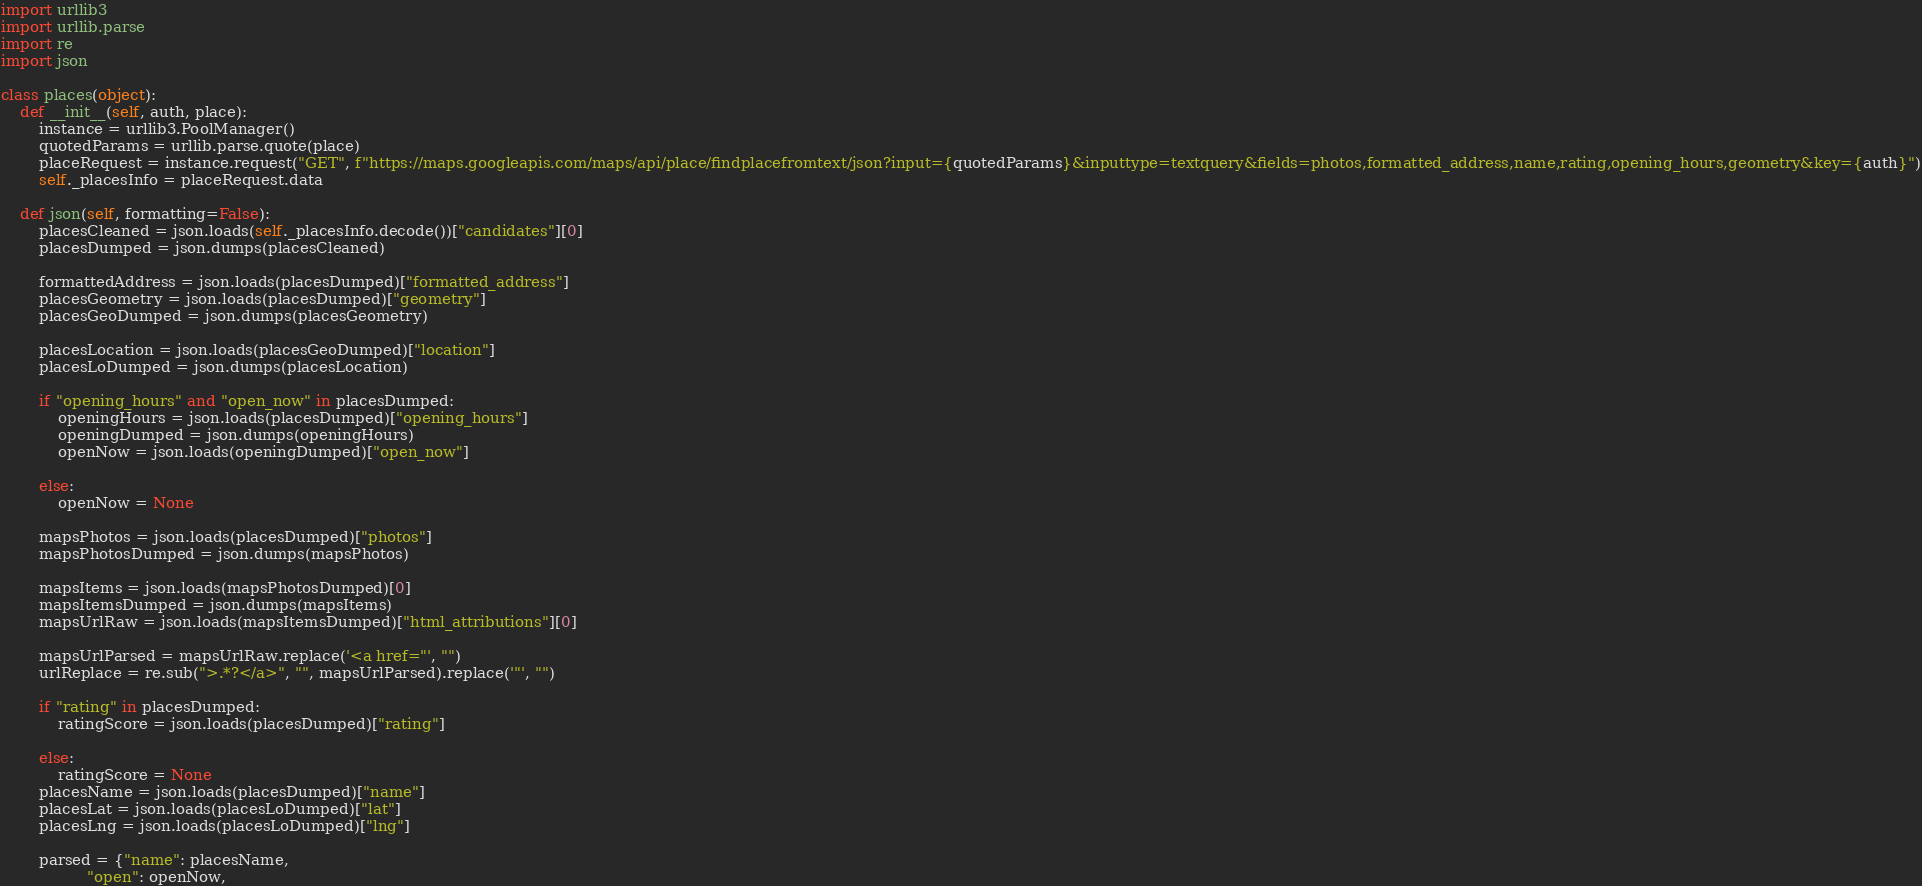<code> <loc_0><loc_0><loc_500><loc_500><_Python_>import urllib3
import urllib.parse
import re
import json

class places(object):
    def __init__(self, auth, place):
        instance = urllib3.PoolManager()
        quotedParams = urllib.parse.quote(place)
        placeRequest = instance.request("GET", f"https://maps.googleapis.com/maps/api/place/findplacefromtext/json?input={quotedParams}&inputtype=textquery&fields=photos,formatted_address,name,rating,opening_hours,geometry&key={auth}")
        self._placesInfo = placeRequest.data

    def json(self, formatting=False):
        placesCleaned = json.loads(self._placesInfo.decode())["candidates"][0]
        placesDumped = json.dumps(placesCleaned)

        formattedAddress = json.loads(placesDumped)["formatted_address"]
        placesGeometry = json.loads(placesDumped)["geometry"]
        placesGeoDumped = json.dumps(placesGeometry)

        placesLocation = json.loads(placesGeoDumped)["location"] 
        placesLoDumped = json.dumps(placesLocation)
        
        if "opening_hours" and "open_now" in placesDumped:
            openingHours = json.loads(placesDumped)["opening_hours"]
            openingDumped = json.dumps(openingHours)
            openNow = json.loads(openingDumped)["open_now"]

        else:
            openNow = None

        mapsPhotos = json.loads(placesDumped)["photos"]
        mapsPhotosDumped = json.dumps(mapsPhotos)

        mapsItems = json.loads(mapsPhotosDumped)[0]
        mapsItemsDumped = json.dumps(mapsItems)
        mapsUrlRaw = json.loads(mapsItemsDumped)["html_attributions"][0]

        mapsUrlParsed = mapsUrlRaw.replace('<a href="', "")
        urlReplace = re.sub(">.*?</a>", "", mapsUrlParsed).replace('"', "")

        if "rating" in placesDumped:
            ratingScore = json.loads(placesDumped)["rating"]

        else:
            ratingScore = None
        placesName = json.loads(placesDumped)["name"]
        placesLat = json.loads(placesLoDumped)["lat"]
        placesLng = json.loads(placesLoDumped)["lng"]

        parsed = {"name": placesName,
                  "open": openNow,</code> 